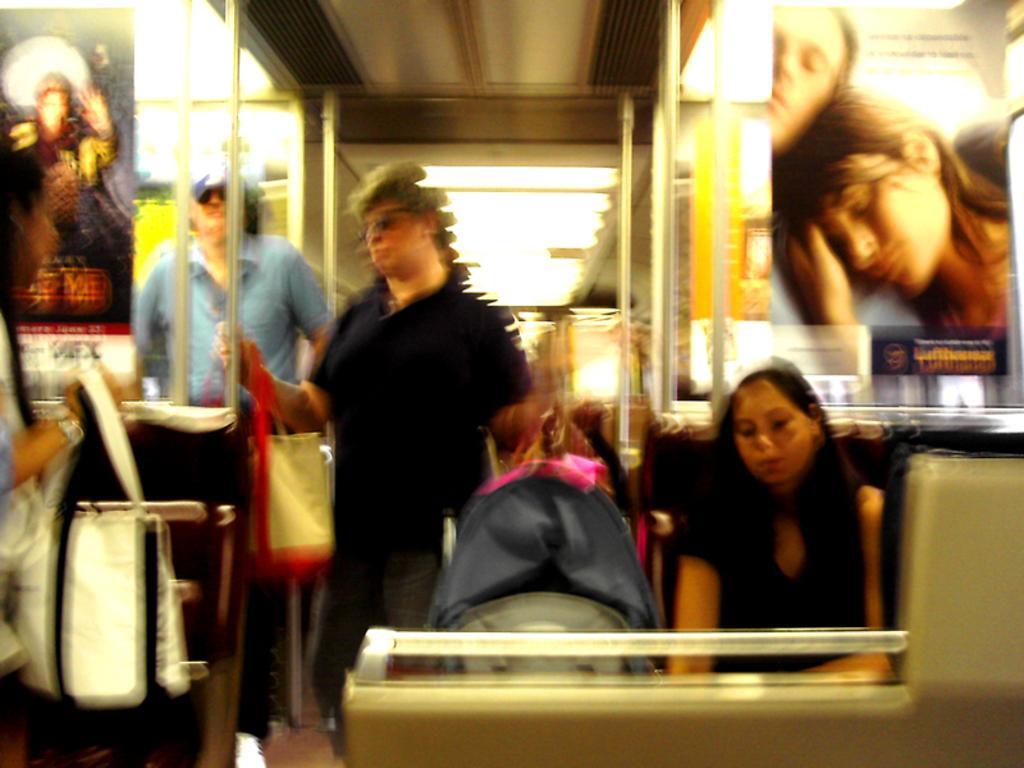How would you summarize this image in a sentence or two? There are two persons standing and holding a carry bags in their hands and there is another lady sitting in the right corner and there is a person standing in the background. 